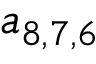Convert formula to latex. <formula><loc_0><loc_0><loc_500><loc_500>a _ { 8 , 7 , 6 }</formula> 